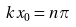Convert formula to latex. <formula><loc_0><loc_0><loc_500><loc_500>k x _ { 0 } = n \pi</formula> 